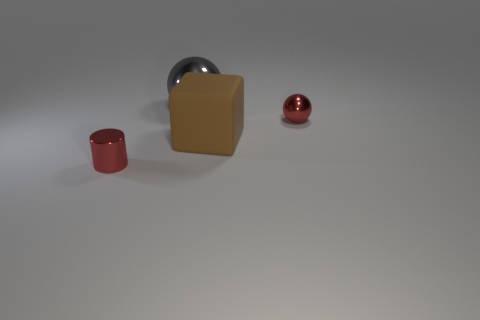Add 2 brown objects. How many objects exist? 6 Subtract all cylinders. How many objects are left? 3 Subtract all gray balls. Subtract all large gray blocks. How many objects are left? 3 Add 4 small shiny objects. How many small shiny objects are left? 6 Add 4 big metallic spheres. How many big metallic spheres exist? 5 Subtract 0 purple blocks. How many objects are left? 4 